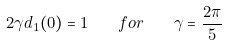Convert formula to latex. <formula><loc_0><loc_0><loc_500><loc_500>2 \gamma d _ { 1 } ( 0 ) = 1 \quad f o r \quad \gamma = \frac { 2 \pi } { 5 }</formula> 